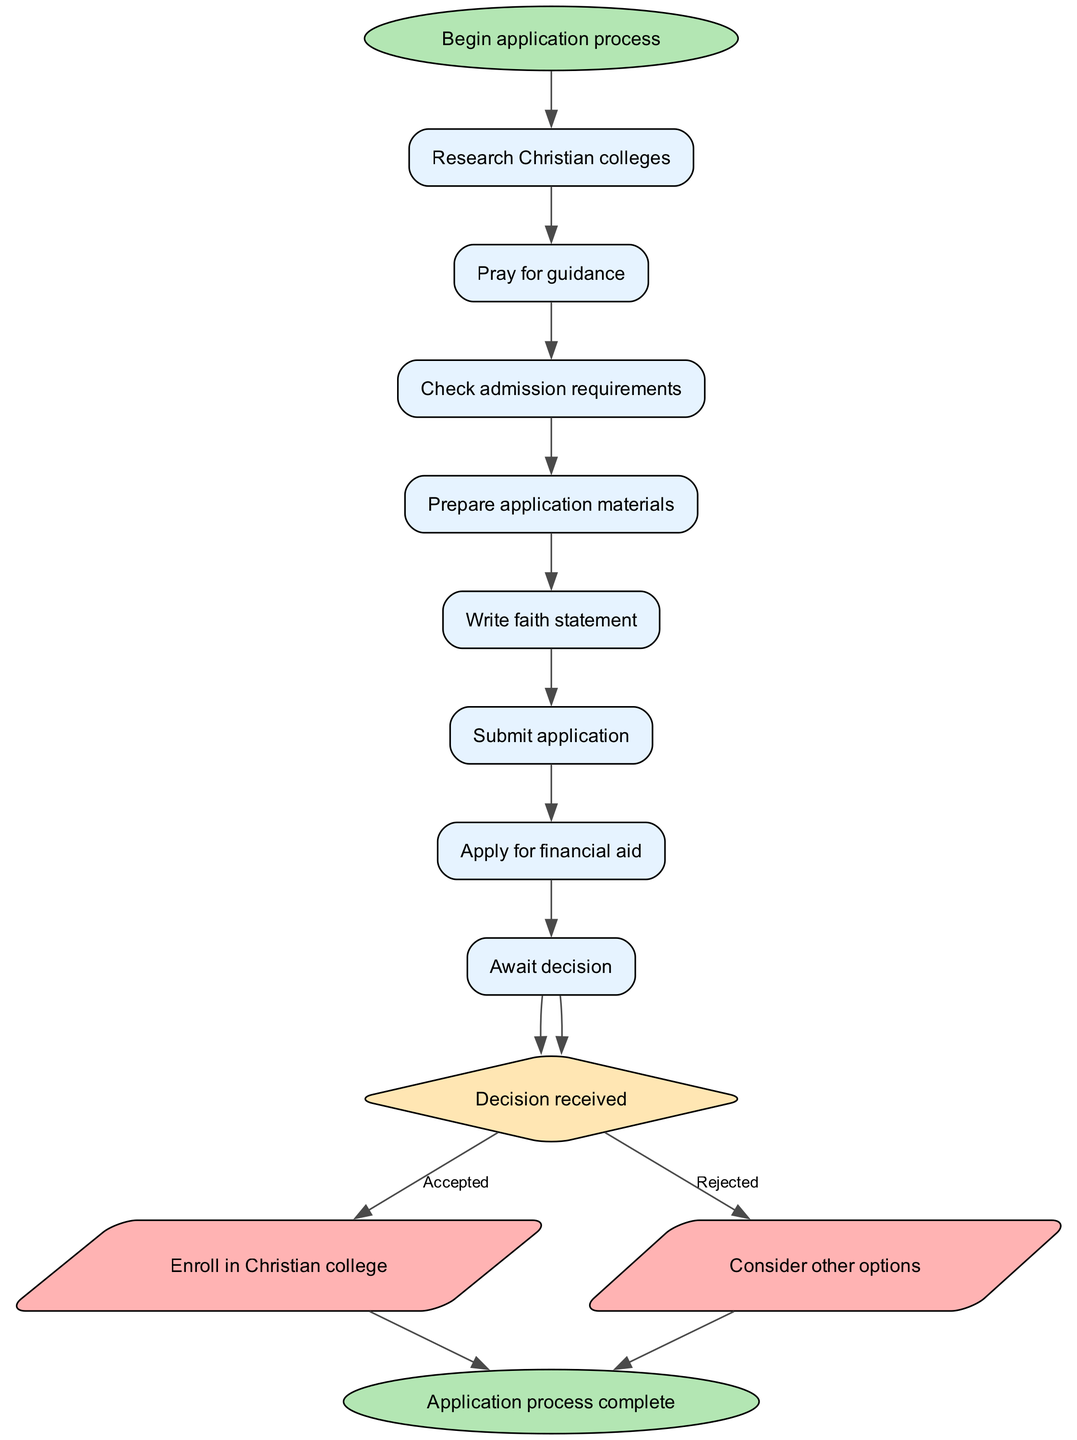What is the first step in the application process? The diagram clearly indicates that the first step in the application process is labeled "Begin application process." This is depicted as the starting point, leading into the first action node.
Answer: Begin application process How many steps are there in the application process? The diagram outlines a series of steps numbered from the initial starting point to the final decision. Counting each of the listed steps reveals there are 8 steps in total, each transitioning to the next one.
Answer: 8 What comes after "Prepare application materials"? Following "Prepare application materials," the diagram indicates the next step is "Write faith statement." This is a direct connection from one step to the next in the flow.
Answer: Write faith statement What is the final action taken after the "Decision received"? The diagram specifies two possible actions depending on the decision outcome: "Enroll in Christian college" for accepted and "Consider other options" for rejected. However, both outcomes ultimately lead to the same final node, indicating that the process concludes there.
Answer: Application process complete If a student is rejected, what should they consider? According to the decision branch in the diagram, if a student is rejected, the suggested next action is to "Consider other options." This provides a clear alternative path contingent on the outcome.
Answer: Consider other options What do you do before checking admission requirements? The flowchart states the step preceding "Check admission requirements" is "Pray for guidance." This suggests a contemplative action prior to the practical steps associated with the application process.
Answer: Pray for guidance How many outcomes are there after the "Decision received" node? There are two distinct outcomes listed under the "Decision received" node: "Enroll in Christian college" and "Consider other options." This indicates the process bifurcates into two paths based on acceptance or rejection.
Answer: 2 Which step directly follows "Submit application"? The diagram illustrates that the step following "Submit application" is "Apply for financial aid." This progression shows the sequence of actions taken after submitting an application.
Answer: Apply for financial aid 